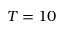Convert formula to latex. <formula><loc_0><loc_0><loc_500><loc_500>T = 1 0</formula> 